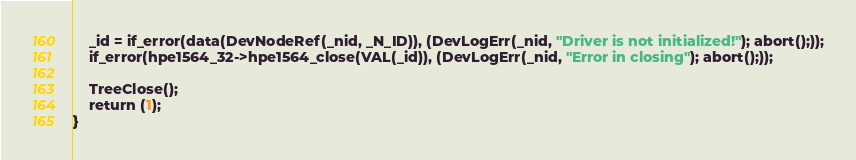<code> <loc_0><loc_0><loc_500><loc_500><_SML_>    _id = if_error(data(DevNodeRef(_nid, _N_ID)), (DevLogErr(_nid, "Driver is not initialized!"); abort();));
    if_error(hpe1564_32->hpe1564_close(VAL(_id)), (DevLogErr(_nid, "Error in closing"); abort();));

    TreeClose();
    return (1);
}</code> 